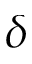<formula> <loc_0><loc_0><loc_500><loc_500>\delta</formula> 